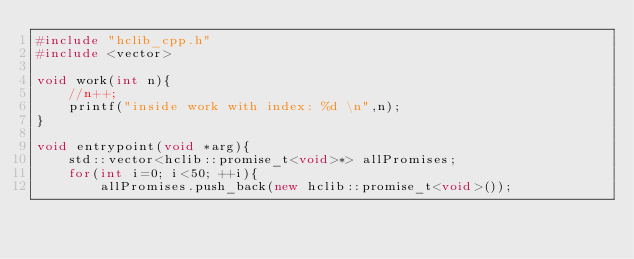Convert code to text. <code><loc_0><loc_0><loc_500><loc_500><_C++_>#include "hclib_cpp.h"
#include <vector>

void work(int n){
    //n++;
    printf("inside work with index: %d \n",n);
}

void entrypoint(void *arg){
    std::vector<hclib::promise_t<void>*> allPromises;
    for(int i=0; i<50; ++i){
        allPromises.push_back(new hclib::promise_t<void>());</code> 